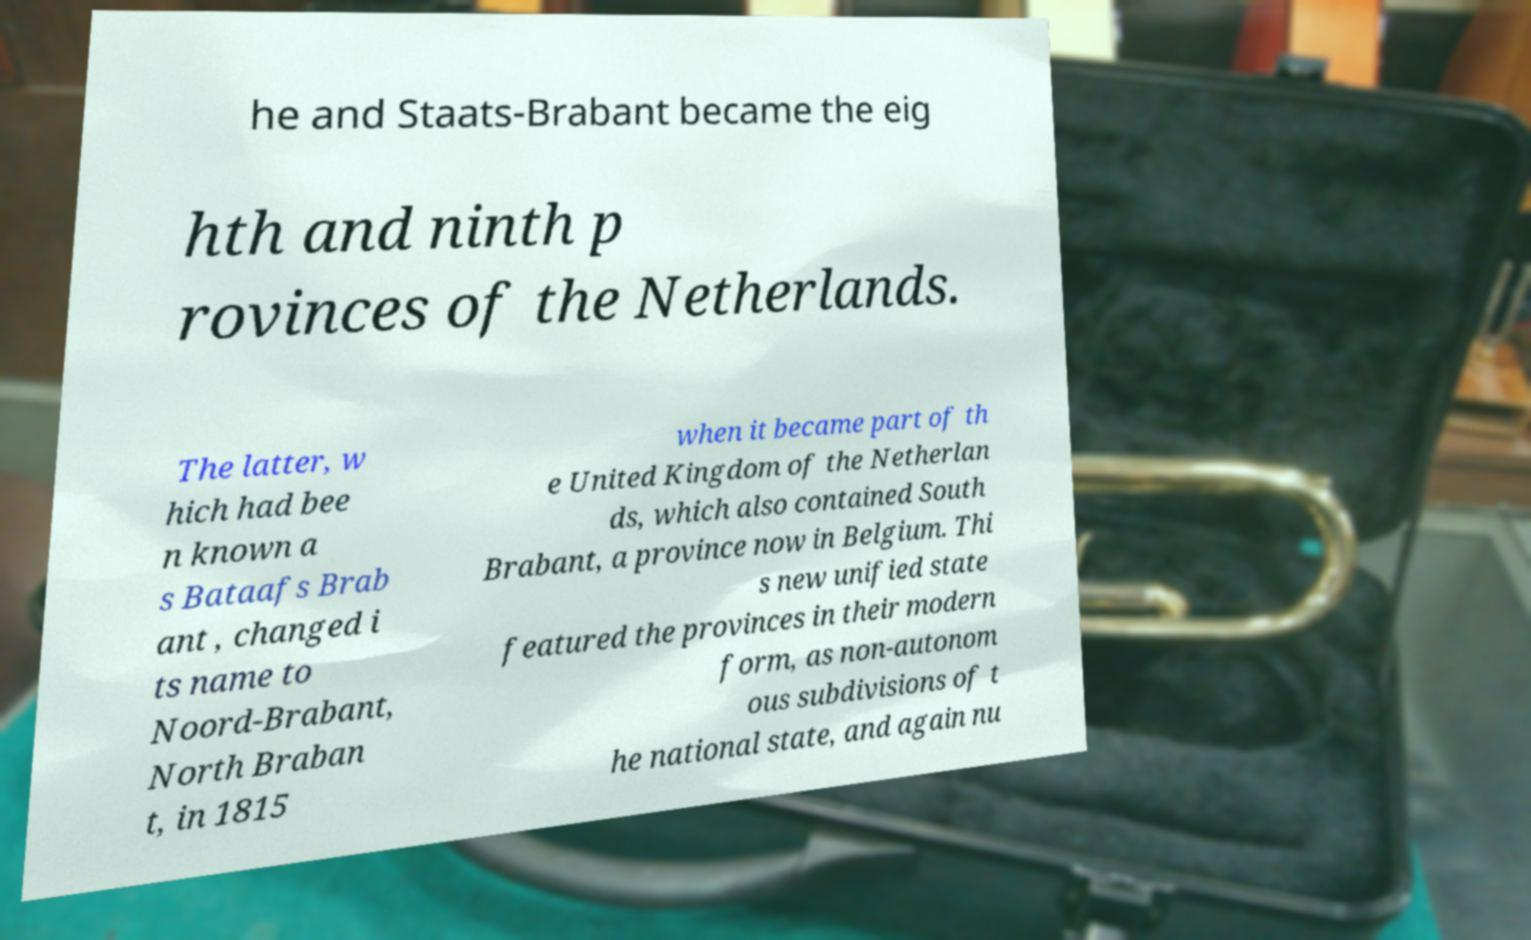Can you read and provide the text displayed in the image?This photo seems to have some interesting text. Can you extract and type it out for me? he and Staats-Brabant became the eig hth and ninth p rovinces of the Netherlands. The latter, w hich had bee n known a s Bataafs Brab ant , changed i ts name to Noord-Brabant, North Braban t, in 1815 when it became part of th e United Kingdom of the Netherlan ds, which also contained South Brabant, a province now in Belgium. Thi s new unified state featured the provinces in their modern form, as non-autonom ous subdivisions of t he national state, and again nu 